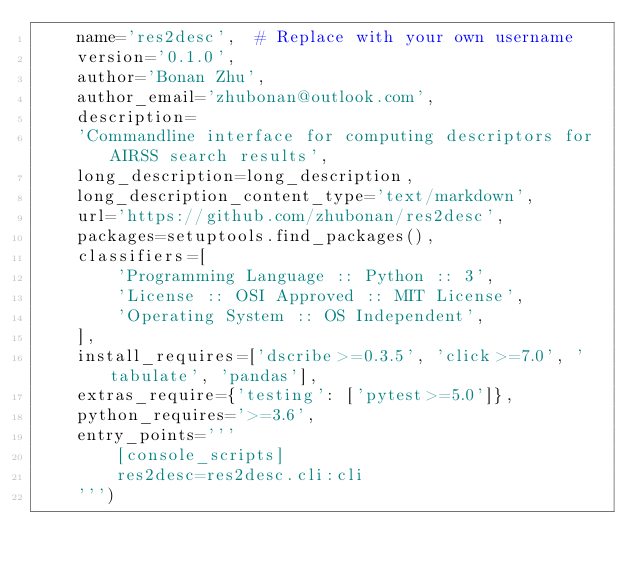Convert code to text. <code><loc_0><loc_0><loc_500><loc_500><_Python_>    name='res2desc',  # Replace with your own username
    version='0.1.0',
    author='Bonan Zhu',
    author_email='zhubonan@outlook.com',
    description=
    'Commandline interface for computing descriptors for AIRSS search results',
    long_description=long_description,
    long_description_content_type='text/markdown',
    url='https://github.com/zhubonan/res2desc',
    packages=setuptools.find_packages(),
    classifiers=[
        'Programming Language :: Python :: 3',
        'License :: OSI Approved :: MIT License',
        'Operating System :: OS Independent',
    ],
    install_requires=['dscribe>=0.3.5', 'click>=7.0', 'tabulate', 'pandas'],
    extras_require={'testing': ['pytest>=5.0']},
    python_requires='>=3.6',
    entry_points='''
        [console_scripts]
        res2desc=res2desc.cli:cli
    ''')
</code> 